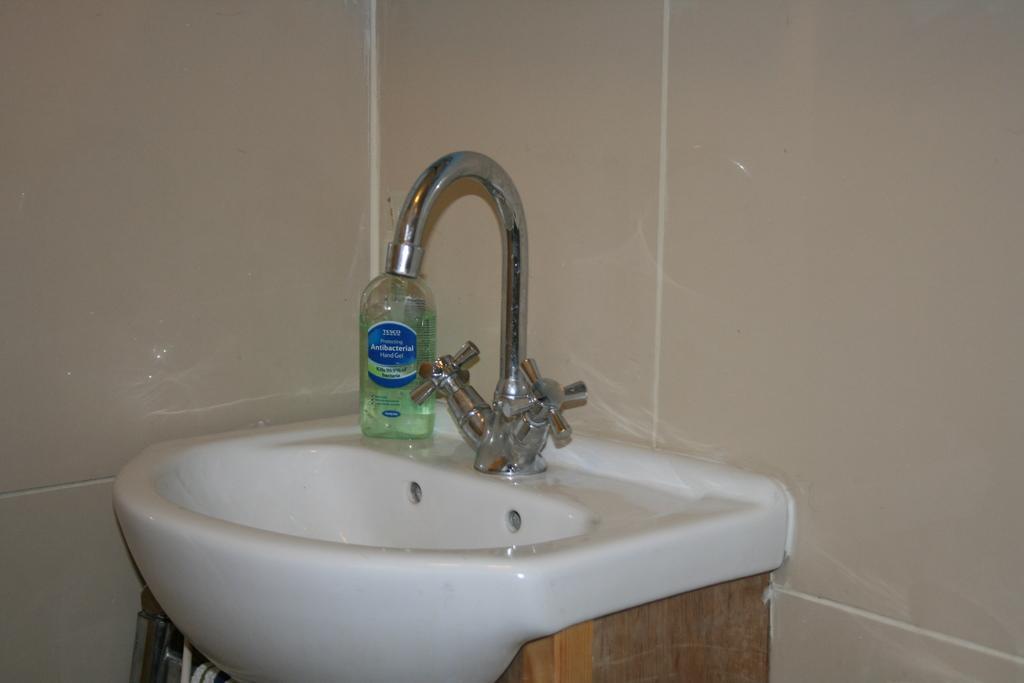Can you describe this image briefly? In the middle of the picture we can see tap, sink and bottle. At the top it is well. At the bottom we can see some objects. 